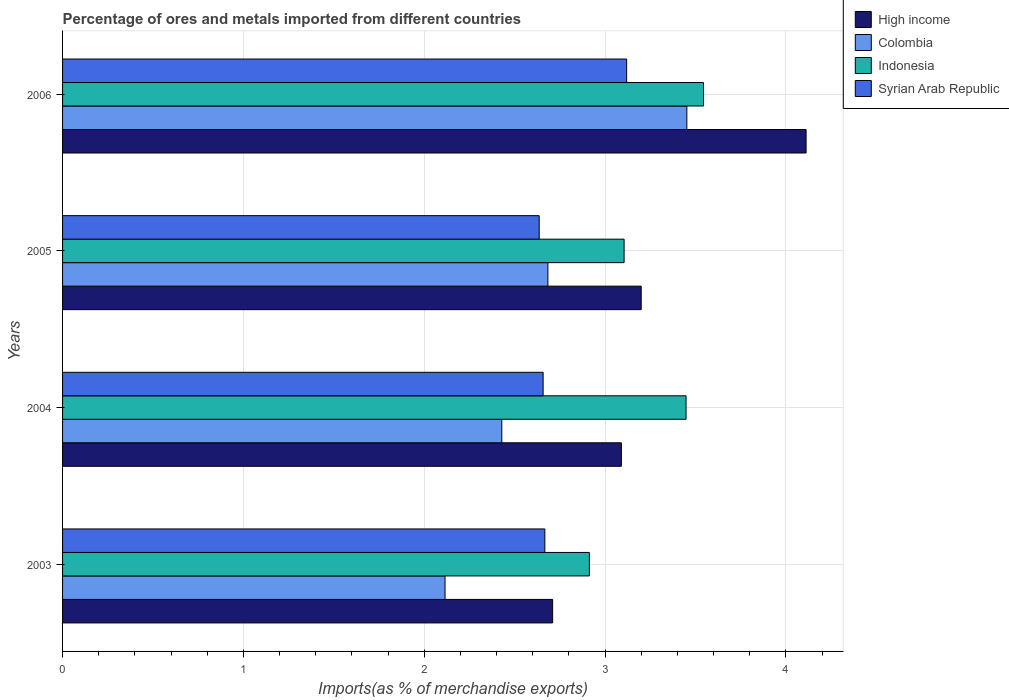Are the number of bars per tick equal to the number of legend labels?
Keep it short and to the point. Yes. How many bars are there on the 2nd tick from the top?
Your answer should be compact. 4. What is the percentage of imports to different countries in Indonesia in 2005?
Your response must be concise. 3.1. Across all years, what is the maximum percentage of imports to different countries in High income?
Make the answer very short. 4.11. Across all years, what is the minimum percentage of imports to different countries in Syrian Arab Republic?
Provide a short and direct response. 2.64. What is the total percentage of imports to different countries in Syrian Arab Republic in the graph?
Offer a terse response. 11.08. What is the difference between the percentage of imports to different countries in Colombia in 2003 and that in 2005?
Your answer should be compact. -0.57. What is the difference between the percentage of imports to different countries in High income in 2004 and the percentage of imports to different countries in Syrian Arab Republic in 2006?
Your response must be concise. -0.03. What is the average percentage of imports to different countries in Colombia per year?
Provide a short and direct response. 2.67. In the year 2004, what is the difference between the percentage of imports to different countries in Syrian Arab Republic and percentage of imports to different countries in Indonesia?
Make the answer very short. -0.79. What is the ratio of the percentage of imports to different countries in Colombia in 2003 to that in 2004?
Provide a succinct answer. 0.87. What is the difference between the highest and the second highest percentage of imports to different countries in Syrian Arab Republic?
Your answer should be compact. 0.45. What is the difference between the highest and the lowest percentage of imports to different countries in Indonesia?
Provide a short and direct response. 0.63. Is the sum of the percentage of imports to different countries in Indonesia in 2003 and 2006 greater than the maximum percentage of imports to different countries in High income across all years?
Your answer should be very brief. Yes. What does the 3rd bar from the top in 2006 represents?
Ensure brevity in your answer.  Colombia. What does the 3rd bar from the bottom in 2004 represents?
Provide a short and direct response. Indonesia. Is it the case that in every year, the sum of the percentage of imports to different countries in High income and percentage of imports to different countries in Indonesia is greater than the percentage of imports to different countries in Syrian Arab Republic?
Ensure brevity in your answer.  Yes. What is the difference between two consecutive major ticks on the X-axis?
Offer a terse response. 1. Are the values on the major ticks of X-axis written in scientific E-notation?
Your response must be concise. No. Does the graph contain grids?
Your answer should be compact. Yes. What is the title of the graph?
Offer a very short reply. Percentage of ores and metals imported from different countries. Does "Azerbaijan" appear as one of the legend labels in the graph?
Ensure brevity in your answer.  No. What is the label or title of the X-axis?
Your answer should be compact. Imports(as % of merchandise exports). What is the Imports(as % of merchandise exports) of High income in 2003?
Ensure brevity in your answer.  2.71. What is the Imports(as % of merchandise exports) of Colombia in 2003?
Ensure brevity in your answer.  2.11. What is the Imports(as % of merchandise exports) in Indonesia in 2003?
Give a very brief answer. 2.91. What is the Imports(as % of merchandise exports) of Syrian Arab Republic in 2003?
Your answer should be compact. 2.67. What is the Imports(as % of merchandise exports) of High income in 2004?
Provide a succinct answer. 3.09. What is the Imports(as % of merchandise exports) of Colombia in 2004?
Offer a terse response. 2.43. What is the Imports(as % of merchandise exports) of Indonesia in 2004?
Ensure brevity in your answer.  3.45. What is the Imports(as % of merchandise exports) in Syrian Arab Republic in 2004?
Make the answer very short. 2.66. What is the Imports(as % of merchandise exports) in High income in 2005?
Your response must be concise. 3.2. What is the Imports(as % of merchandise exports) of Colombia in 2005?
Ensure brevity in your answer.  2.68. What is the Imports(as % of merchandise exports) of Indonesia in 2005?
Give a very brief answer. 3.1. What is the Imports(as % of merchandise exports) of Syrian Arab Republic in 2005?
Provide a short and direct response. 2.64. What is the Imports(as % of merchandise exports) in High income in 2006?
Ensure brevity in your answer.  4.11. What is the Imports(as % of merchandise exports) in Colombia in 2006?
Offer a very short reply. 3.45. What is the Imports(as % of merchandise exports) in Indonesia in 2006?
Offer a terse response. 3.54. What is the Imports(as % of merchandise exports) in Syrian Arab Republic in 2006?
Your answer should be compact. 3.12. Across all years, what is the maximum Imports(as % of merchandise exports) of High income?
Your response must be concise. 4.11. Across all years, what is the maximum Imports(as % of merchandise exports) in Colombia?
Make the answer very short. 3.45. Across all years, what is the maximum Imports(as % of merchandise exports) in Indonesia?
Offer a terse response. 3.54. Across all years, what is the maximum Imports(as % of merchandise exports) in Syrian Arab Republic?
Offer a very short reply. 3.12. Across all years, what is the minimum Imports(as % of merchandise exports) in High income?
Offer a very short reply. 2.71. Across all years, what is the minimum Imports(as % of merchandise exports) of Colombia?
Offer a terse response. 2.11. Across all years, what is the minimum Imports(as % of merchandise exports) in Indonesia?
Give a very brief answer. 2.91. Across all years, what is the minimum Imports(as % of merchandise exports) in Syrian Arab Republic?
Provide a short and direct response. 2.64. What is the total Imports(as % of merchandise exports) of High income in the graph?
Your answer should be very brief. 13.11. What is the total Imports(as % of merchandise exports) in Colombia in the graph?
Offer a terse response. 10.68. What is the total Imports(as % of merchandise exports) of Indonesia in the graph?
Your response must be concise. 13.01. What is the total Imports(as % of merchandise exports) of Syrian Arab Republic in the graph?
Offer a terse response. 11.08. What is the difference between the Imports(as % of merchandise exports) in High income in 2003 and that in 2004?
Make the answer very short. -0.38. What is the difference between the Imports(as % of merchandise exports) of Colombia in 2003 and that in 2004?
Keep it short and to the point. -0.31. What is the difference between the Imports(as % of merchandise exports) of Indonesia in 2003 and that in 2004?
Provide a short and direct response. -0.53. What is the difference between the Imports(as % of merchandise exports) in Syrian Arab Republic in 2003 and that in 2004?
Your answer should be very brief. 0.01. What is the difference between the Imports(as % of merchandise exports) in High income in 2003 and that in 2005?
Your response must be concise. -0.49. What is the difference between the Imports(as % of merchandise exports) in Colombia in 2003 and that in 2005?
Your response must be concise. -0.57. What is the difference between the Imports(as % of merchandise exports) of Indonesia in 2003 and that in 2005?
Give a very brief answer. -0.19. What is the difference between the Imports(as % of merchandise exports) in Syrian Arab Republic in 2003 and that in 2005?
Make the answer very short. 0.03. What is the difference between the Imports(as % of merchandise exports) in High income in 2003 and that in 2006?
Your answer should be very brief. -1.4. What is the difference between the Imports(as % of merchandise exports) in Colombia in 2003 and that in 2006?
Keep it short and to the point. -1.34. What is the difference between the Imports(as % of merchandise exports) in Indonesia in 2003 and that in 2006?
Your answer should be compact. -0.63. What is the difference between the Imports(as % of merchandise exports) in Syrian Arab Republic in 2003 and that in 2006?
Ensure brevity in your answer.  -0.45. What is the difference between the Imports(as % of merchandise exports) in High income in 2004 and that in 2005?
Give a very brief answer. -0.11. What is the difference between the Imports(as % of merchandise exports) of Colombia in 2004 and that in 2005?
Provide a succinct answer. -0.25. What is the difference between the Imports(as % of merchandise exports) in Indonesia in 2004 and that in 2005?
Your response must be concise. 0.34. What is the difference between the Imports(as % of merchandise exports) of Syrian Arab Republic in 2004 and that in 2005?
Your response must be concise. 0.02. What is the difference between the Imports(as % of merchandise exports) in High income in 2004 and that in 2006?
Your answer should be very brief. -1.02. What is the difference between the Imports(as % of merchandise exports) in Colombia in 2004 and that in 2006?
Your response must be concise. -1.02. What is the difference between the Imports(as % of merchandise exports) in Indonesia in 2004 and that in 2006?
Provide a succinct answer. -0.1. What is the difference between the Imports(as % of merchandise exports) in Syrian Arab Republic in 2004 and that in 2006?
Ensure brevity in your answer.  -0.46. What is the difference between the Imports(as % of merchandise exports) of High income in 2005 and that in 2006?
Give a very brief answer. -0.91. What is the difference between the Imports(as % of merchandise exports) in Colombia in 2005 and that in 2006?
Keep it short and to the point. -0.77. What is the difference between the Imports(as % of merchandise exports) of Indonesia in 2005 and that in 2006?
Offer a terse response. -0.44. What is the difference between the Imports(as % of merchandise exports) in Syrian Arab Republic in 2005 and that in 2006?
Make the answer very short. -0.48. What is the difference between the Imports(as % of merchandise exports) of High income in 2003 and the Imports(as % of merchandise exports) of Colombia in 2004?
Your answer should be very brief. 0.28. What is the difference between the Imports(as % of merchandise exports) in High income in 2003 and the Imports(as % of merchandise exports) in Indonesia in 2004?
Keep it short and to the point. -0.74. What is the difference between the Imports(as % of merchandise exports) of High income in 2003 and the Imports(as % of merchandise exports) of Syrian Arab Republic in 2004?
Your answer should be compact. 0.05. What is the difference between the Imports(as % of merchandise exports) in Colombia in 2003 and the Imports(as % of merchandise exports) in Indonesia in 2004?
Offer a very short reply. -1.33. What is the difference between the Imports(as % of merchandise exports) in Colombia in 2003 and the Imports(as % of merchandise exports) in Syrian Arab Republic in 2004?
Offer a terse response. -0.54. What is the difference between the Imports(as % of merchandise exports) in Indonesia in 2003 and the Imports(as % of merchandise exports) in Syrian Arab Republic in 2004?
Offer a very short reply. 0.26. What is the difference between the Imports(as % of merchandise exports) of High income in 2003 and the Imports(as % of merchandise exports) of Colombia in 2005?
Give a very brief answer. 0.03. What is the difference between the Imports(as % of merchandise exports) of High income in 2003 and the Imports(as % of merchandise exports) of Indonesia in 2005?
Provide a succinct answer. -0.4. What is the difference between the Imports(as % of merchandise exports) of High income in 2003 and the Imports(as % of merchandise exports) of Syrian Arab Republic in 2005?
Your answer should be very brief. 0.07. What is the difference between the Imports(as % of merchandise exports) in Colombia in 2003 and the Imports(as % of merchandise exports) in Indonesia in 2005?
Make the answer very short. -0.99. What is the difference between the Imports(as % of merchandise exports) in Colombia in 2003 and the Imports(as % of merchandise exports) in Syrian Arab Republic in 2005?
Offer a terse response. -0.52. What is the difference between the Imports(as % of merchandise exports) in Indonesia in 2003 and the Imports(as % of merchandise exports) in Syrian Arab Republic in 2005?
Your answer should be very brief. 0.28. What is the difference between the Imports(as % of merchandise exports) of High income in 2003 and the Imports(as % of merchandise exports) of Colombia in 2006?
Your answer should be very brief. -0.74. What is the difference between the Imports(as % of merchandise exports) of High income in 2003 and the Imports(as % of merchandise exports) of Indonesia in 2006?
Provide a succinct answer. -0.83. What is the difference between the Imports(as % of merchandise exports) in High income in 2003 and the Imports(as % of merchandise exports) in Syrian Arab Republic in 2006?
Provide a succinct answer. -0.41. What is the difference between the Imports(as % of merchandise exports) of Colombia in 2003 and the Imports(as % of merchandise exports) of Indonesia in 2006?
Offer a very short reply. -1.43. What is the difference between the Imports(as % of merchandise exports) in Colombia in 2003 and the Imports(as % of merchandise exports) in Syrian Arab Republic in 2006?
Your response must be concise. -1. What is the difference between the Imports(as % of merchandise exports) of Indonesia in 2003 and the Imports(as % of merchandise exports) of Syrian Arab Republic in 2006?
Offer a very short reply. -0.21. What is the difference between the Imports(as % of merchandise exports) of High income in 2004 and the Imports(as % of merchandise exports) of Colombia in 2005?
Ensure brevity in your answer.  0.41. What is the difference between the Imports(as % of merchandise exports) of High income in 2004 and the Imports(as % of merchandise exports) of Indonesia in 2005?
Provide a succinct answer. -0.01. What is the difference between the Imports(as % of merchandise exports) of High income in 2004 and the Imports(as % of merchandise exports) of Syrian Arab Republic in 2005?
Give a very brief answer. 0.45. What is the difference between the Imports(as % of merchandise exports) of Colombia in 2004 and the Imports(as % of merchandise exports) of Indonesia in 2005?
Ensure brevity in your answer.  -0.68. What is the difference between the Imports(as % of merchandise exports) of Colombia in 2004 and the Imports(as % of merchandise exports) of Syrian Arab Republic in 2005?
Your response must be concise. -0.21. What is the difference between the Imports(as % of merchandise exports) of Indonesia in 2004 and the Imports(as % of merchandise exports) of Syrian Arab Republic in 2005?
Your response must be concise. 0.81. What is the difference between the Imports(as % of merchandise exports) in High income in 2004 and the Imports(as % of merchandise exports) in Colombia in 2006?
Offer a very short reply. -0.36. What is the difference between the Imports(as % of merchandise exports) in High income in 2004 and the Imports(as % of merchandise exports) in Indonesia in 2006?
Provide a short and direct response. -0.45. What is the difference between the Imports(as % of merchandise exports) in High income in 2004 and the Imports(as % of merchandise exports) in Syrian Arab Republic in 2006?
Provide a short and direct response. -0.03. What is the difference between the Imports(as % of merchandise exports) of Colombia in 2004 and the Imports(as % of merchandise exports) of Indonesia in 2006?
Offer a terse response. -1.12. What is the difference between the Imports(as % of merchandise exports) in Colombia in 2004 and the Imports(as % of merchandise exports) in Syrian Arab Republic in 2006?
Offer a very short reply. -0.69. What is the difference between the Imports(as % of merchandise exports) in Indonesia in 2004 and the Imports(as % of merchandise exports) in Syrian Arab Republic in 2006?
Your answer should be very brief. 0.33. What is the difference between the Imports(as % of merchandise exports) of High income in 2005 and the Imports(as % of merchandise exports) of Colombia in 2006?
Offer a very short reply. -0.25. What is the difference between the Imports(as % of merchandise exports) of High income in 2005 and the Imports(as % of merchandise exports) of Indonesia in 2006?
Keep it short and to the point. -0.34. What is the difference between the Imports(as % of merchandise exports) in High income in 2005 and the Imports(as % of merchandise exports) in Syrian Arab Republic in 2006?
Offer a terse response. 0.08. What is the difference between the Imports(as % of merchandise exports) of Colombia in 2005 and the Imports(as % of merchandise exports) of Indonesia in 2006?
Keep it short and to the point. -0.86. What is the difference between the Imports(as % of merchandise exports) of Colombia in 2005 and the Imports(as % of merchandise exports) of Syrian Arab Republic in 2006?
Provide a succinct answer. -0.44. What is the difference between the Imports(as % of merchandise exports) of Indonesia in 2005 and the Imports(as % of merchandise exports) of Syrian Arab Republic in 2006?
Your response must be concise. -0.01. What is the average Imports(as % of merchandise exports) in High income per year?
Your answer should be very brief. 3.28. What is the average Imports(as % of merchandise exports) of Colombia per year?
Give a very brief answer. 2.67. What is the average Imports(as % of merchandise exports) in Indonesia per year?
Make the answer very short. 3.25. What is the average Imports(as % of merchandise exports) of Syrian Arab Republic per year?
Give a very brief answer. 2.77. In the year 2003, what is the difference between the Imports(as % of merchandise exports) of High income and Imports(as % of merchandise exports) of Colombia?
Your answer should be very brief. 0.59. In the year 2003, what is the difference between the Imports(as % of merchandise exports) in High income and Imports(as % of merchandise exports) in Indonesia?
Make the answer very short. -0.2. In the year 2003, what is the difference between the Imports(as % of merchandise exports) in High income and Imports(as % of merchandise exports) in Syrian Arab Republic?
Offer a terse response. 0.04. In the year 2003, what is the difference between the Imports(as % of merchandise exports) of Colombia and Imports(as % of merchandise exports) of Indonesia?
Offer a very short reply. -0.8. In the year 2003, what is the difference between the Imports(as % of merchandise exports) of Colombia and Imports(as % of merchandise exports) of Syrian Arab Republic?
Provide a short and direct response. -0.55. In the year 2003, what is the difference between the Imports(as % of merchandise exports) in Indonesia and Imports(as % of merchandise exports) in Syrian Arab Republic?
Offer a terse response. 0.25. In the year 2004, what is the difference between the Imports(as % of merchandise exports) in High income and Imports(as % of merchandise exports) in Colombia?
Your answer should be compact. 0.66. In the year 2004, what is the difference between the Imports(as % of merchandise exports) of High income and Imports(as % of merchandise exports) of Indonesia?
Your answer should be compact. -0.36. In the year 2004, what is the difference between the Imports(as % of merchandise exports) in High income and Imports(as % of merchandise exports) in Syrian Arab Republic?
Keep it short and to the point. 0.43. In the year 2004, what is the difference between the Imports(as % of merchandise exports) of Colombia and Imports(as % of merchandise exports) of Indonesia?
Ensure brevity in your answer.  -1.02. In the year 2004, what is the difference between the Imports(as % of merchandise exports) of Colombia and Imports(as % of merchandise exports) of Syrian Arab Republic?
Make the answer very short. -0.23. In the year 2004, what is the difference between the Imports(as % of merchandise exports) in Indonesia and Imports(as % of merchandise exports) in Syrian Arab Republic?
Your response must be concise. 0.79. In the year 2005, what is the difference between the Imports(as % of merchandise exports) of High income and Imports(as % of merchandise exports) of Colombia?
Keep it short and to the point. 0.52. In the year 2005, what is the difference between the Imports(as % of merchandise exports) of High income and Imports(as % of merchandise exports) of Indonesia?
Provide a succinct answer. 0.09. In the year 2005, what is the difference between the Imports(as % of merchandise exports) of High income and Imports(as % of merchandise exports) of Syrian Arab Republic?
Offer a terse response. 0.56. In the year 2005, what is the difference between the Imports(as % of merchandise exports) of Colombia and Imports(as % of merchandise exports) of Indonesia?
Your answer should be compact. -0.42. In the year 2005, what is the difference between the Imports(as % of merchandise exports) in Colombia and Imports(as % of merchandise exports) in Syrian Arab Republic?
Your response must be concise. 0.05. In the year 2005, what is the difference between the Imports(as % of merchandise exports) of Indonesia and Imports(as % of merchandise exports) of Syrian Arab Republic?
Offer a terse response. 0.47. In the year 2006, what is the difference between the Imports(as % of merchandise exports) in High income and Imports(as % of merchandise exports) in Colombia?
Give a very brief answer. 0.66. In the year 2006, what is the difference between the Imports(as % of merchandise exports) in High income and Imports(as % of merchandise exports) in Indonesia?
Ensure brevity in your answer.  0.57. In the year 2006, what is the difference between the Imports(as % of merchandise exports) in High income and Imports(as % of merchandise exports) in Syrian Arab Republic?
Provide a short and direct response. 0.99. In the year 2006, what is the difference between the Imports(as % of merchandise exports) of Colombia and Imports(as % of merchandise exports) of Indonesia?
Your answer should be compact. -0.09. In the year 2006, what is the difference between the Imports(as % of merchandise exports) of Colombia and Imports(as % of merchandise exports) of Syrian Arab Republic?
Your answer should be very brief. 0.33. In the year 2006, what is the difference between the Imports(as % of merchandise exports) in Indonesia and Imports(as % of merchandise exports) in Syrian Arab Republic?
Ensure brevity in your answer.  0.43. What is the ratio of the Imports(as % of merchandise exports) in High income in 2003 to that in 2004?
Ensure brevity in your answer.  0.88. What is the ratio of the Imports(as % of merchandise exports) in Colombia in 2003 to that in 2004?
Make the answer very short. 0.87. What is the ratio of the Imports(as % of merchandise exports) of Indonesia in 2003 to that in 2004?
Provide a short and direct response. 0.84. What is the ratio of the Imports(as % of merchandise exports) of High income in 2003 to that in 2005?
Offer a terse response. 0.85. What is the ratio of the Imports(as % of merchandise exports) in Colombia in 2003 to that in 2005?
Provide a succinct answer. 0.79. What is the ratio of the Imports(as % of merchandise exports) of Indonesia in 2003 to that in 2005?
Your response must be concise. 0.94. What is the ratio of the Imports(as % of merchandise exports) in Syrian Arab Republic in 2003 to that in 2005?
Keep it short and to the point. 1.01. What is the ratio of the Imports(as % of merchandise exports) of High income in 2003 to that in 2006?
Give a very brief answer. 0.66. What is the ratio of the Imports(as % of merchandise exports) in Colombia in 2003 to that in 2006?
Your response must be concise. 0.61. What is the ratio of the Imports(as % of merchandise exports) of Indonesia in 2003 to that in 2006?
Your answer should be compact. 0.82. What is the ratio of the Imports(as % of merchandise exports) in Syrian Arab Republic in 2003 to that in 2006?
Give a very brief answer. 0.85. What is the ratio of the Imports(as % of merchandise exports) of High income in 2004 to that in 2005?
Your answer should be compact. 0.97. What is the ratio of the Imports(as % of merchandise exports) in Colombia in 2004 to that in 2005?
Keep it short and to the point. 0.91. What is the ratio of the Imports(as % of merchandise exports) of Indonesia in 2004 to that in 2005?
Keep it short and to the point. 1.11. What is the ratio of the Imports(as % of merchandise exports) of Syrian Arab Republic in 2004 to that in 2005?
Your response must be concise. 1.01. What is the ratio of the Imports(as % of merchandise exports) in High income in 2004 to that in 2006?
Your response must be concise. 0.75. What is the ratio of the Imports(as % of merchandise exports) in Colombia in 2004 to that in 2006?
Provide a succinct answer. 0.7. What is the ratio of the Imports(as % of merchandise exports) of Indonesia in 2004 to that in 2006?
Your answer should be compact. 0.97. What is the ratio of the Imports(as % of merchandise exports) of Syrian Arab Republic in 2004 to that in 2006?
Give a very brief answer. 0.85. What is the ratio of the Imports(as % of merchandise exports) in High income in 2005 to that in 2006?
Ensure brevity in your answer.  0.78. What is the ratio of the Imports(as % of merchandise exports) of Colombia in 2005 to that in 2006?
Keep it short and to the point. 0.78. What is the ratio of the Imports(as % of merchandise exports) of Indonesia in 2005 to that in 2006?
Provide a succinct answer. 0.88. What is the ratio of the Imports(as % of merchandise exports) of Syrian Arab Republic in 2005 to that in 2006?
Keep it short and to the point. 0.84. What is the difference between the highest and the second highest Imports(as % of merchandise exports) in High income?
Provide a succinct answer. 0.91. What is the difference between the highest and the second highest Imports(as % of merchandise exports) in Colombia?
Keep it short and to the point. 0.77. What is the difference between the highest and the second highest Imports(as % of merchandise exports) in Indonesia?
Keep it short and to the point. 0.1. What is the difference between the highest and the second highest Imports(as % of merchandise exports) in Syrian Arab Republic?
Give a very brief answer. 0.45. What is the difference between the highest and the lowest Imports(as % of merchandise exports) in High income?
Your answer should be compact. 1.4. What is the difference between the highest and the lowest Imports(as % of merchandise exports) in Colombia?
Provide a short and direct response. 1.34. What is the difference between the highest and the lowest Imports(as % of merchandise exports) of Indonesia?
Provide a short and direct response. 0.63. What is the difference between the highest and the lowest Imports(as % of merchandise exports) in Syrian Arab Republic?
Make the answer very short. 0.48. 